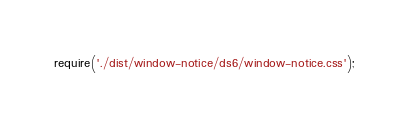Convert code to text. <code><loc_0><loc_0><loc_500><loc_500><_JavaScript_>require('./dist/window-notice/ds6/window-notice.css');
</code> 